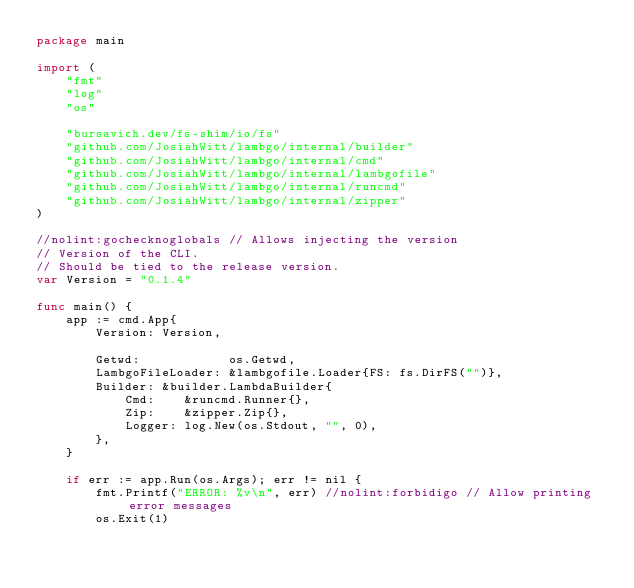<code> <loc_0><loc_0><loc_500><loc_500><_Go_>package main

import (
	"fmt"
	"log"
	"os"

	"bursavich.dev/fs-shim/io/fs"
	"github.com/JosiahWitt/lambgo/internal/builder"
	"github.com/JosiahWitt/lambgo/internal/cmd"
	"github.com/JosiahWitt/lambgo/internal/lambgofile"
	"github.com/JosiahWitt/lambgo/internal/runcmd"
	"github.com/JosiahWitt/lambgo/internal/zipper"
)

//nolint:gochecknoglobals // Allows injecting the version
// Version of the CLI.
// Should be tied to the release version.
var Version = "0.1.4"

func main() {
	app := cmd.App{
		Version: Version,

		Getwd:            os.Getwd,
		LambgoFileLoader: &lambgofile.Loader{FS: fs.DirFS("")},
		Builder: &builder.LambdaBuilder{
			Cmd:    &runcmd.Runner{},
			Zip:    &zipper.Zip{},
			Logger: log.New(os.Stdout, "", 0),
		},
	}

	if err := app.Run(os.Args); err != nil {
		fmt.Printf("ERROR: %v\n", err) //nolint:forbidigo // Allow printing error messages
		os.Exit(1)</code> 